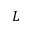Convert formula to latex. <formula><loc_0><loc_0><loc_500><loc_500>L</formula> 